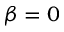<formula> <loc_0><loc_0><loc_500><loc_500>\beta = 0</formula> 